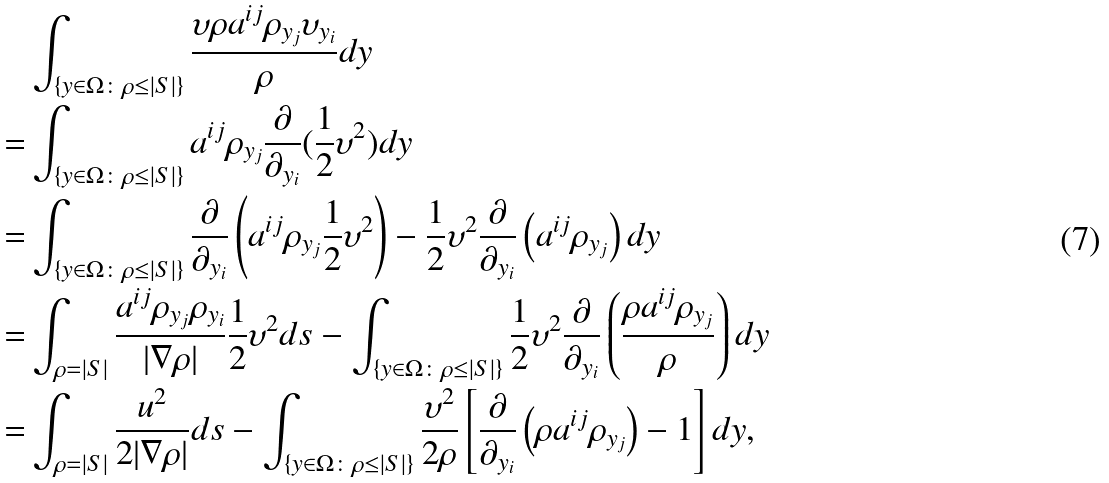<formula> <loc_0><loc_0><loc_500><loc_500>& \int _ { \{ y \in \Omega \colon \rho \leq | S | \} } \frac { \upsilon \rho a ^ { i j } \rho _ { y _ { j } } \upsilon _ { y _ { i } } } { \rho } d y \\ = & \int _ { \{ y \in \Omega \colon \rho \leq | S | \} } a ^ { i j } \rho _ { y _ { j } } \frac { \partial } { \partial _ { y _ { i } } } ( \frac { 1 } { 2 } \upsilon ^ { 2 } ) d y \\ = & \int _ { \{ y \in \Omega \colon \rho \leq | S | \} } \frac { \partial } { \partial _ { y _ { i } } } \left ( a ^ { i j } \rho _ { y _ { j } } \frac { 1 } { 2 } \upsilon ^ { 2 } \right ) - \frac { 1 } { 2 } \upsilon ^ { 2 } \frac { \partial } { \partial _ { y _ { i } } } \left ( a ^ { i j } \rho _ { y _ { j } } \right ) d y \\ = & \int _ { \rho = | S | } \frac { a ^ { i j } \rho _ { y _ { j } } \rho _ { y _ { i } } } { | \nabla \rho | } \frac { 1 } { 2 } \upsilon ^ { 2 } d s - \int _ { \{ y \in \Omega \colon \rho \leq | S | \} } \frac { 1 } { 2 } \upsilon ^ { 2 } \frac { \partial } { \partial _ { y _ { i } } } \left ( \frac { \rho a ^ { i j } \rho _ { y _ { j } } } { \rho } \right ) d y \\ = & \int _ { \rho = | S | } \frac { u ^ { 2 } } { 2 | \nabla \rho | } d s - \int _ { \{ y \in \Omega \colon \rho \leq | S | \} } \frac { \upsilon ^ { 2 } } { 2 \rho } \left [ \frac { \partial } { \partial _ { y _ { i } } } \left ( \rho a ^ { i j } \rho _ { y _ { j } } \right ) - 1 \right ] d y ,</formula> 